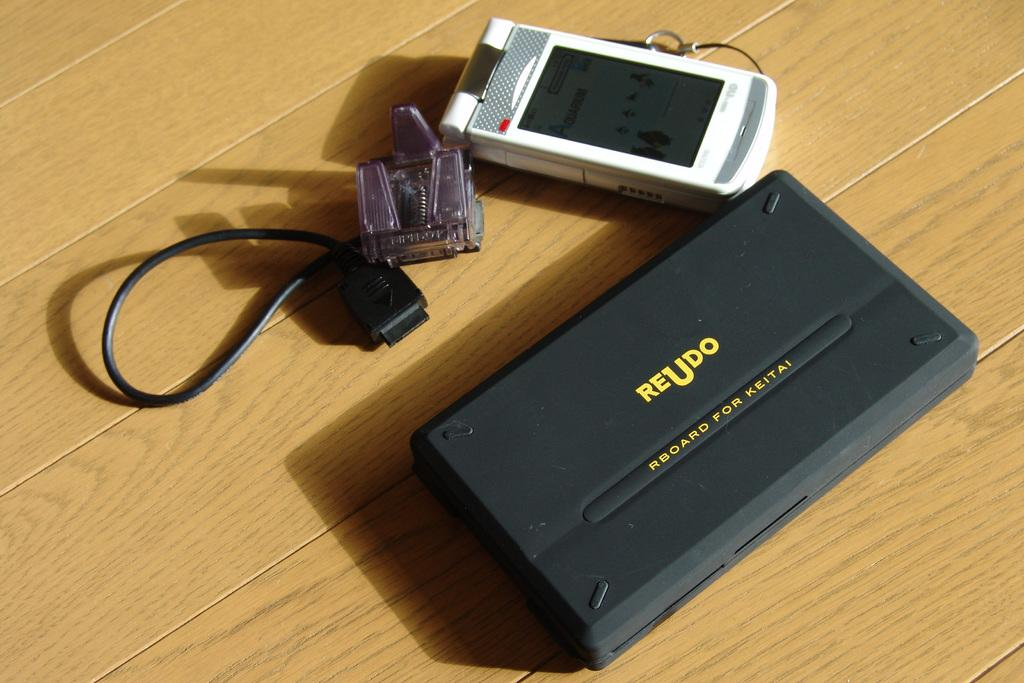Provide a one-sentence caption for the provided image. An rboard made by Reudo sits on a wooden table. 